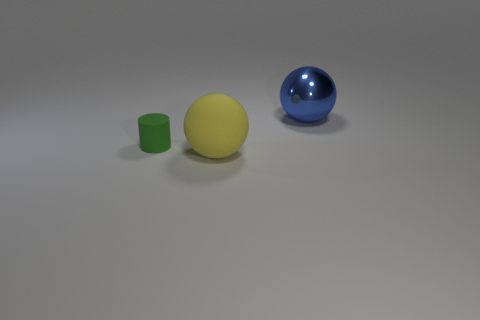Is there anything else that is the same material as the blue thing?
Keep it short and to the point. No. Is there any other thing that has the same size as the green rubber object?
Give a very brief answer. No. There is a object that is right of the small object and behind the yellow matte sphere; what is its shape?
Provide a succinct answer. Sphere. Are there the same number of yellow matte spheres that are to the right of the large yellow matte thing and large blue shiny balls to the left of the green rubber cylinder?
Keep it short and to the point. Yes. Are there any large red balls made of the same material as the cylinder?
Offer a terse response. No. Does the big sphere that is in front of the small rubber thing have the same material as the blue sphere?
Your response must be concise. No. What is the size of the thing that is on the left side of the metallic sphere and right of the matte cylinder?
Your answer should be very brief. Large. The large matte ball has what color?
Ensure brevity in your answer.  Yellow. What number of cyan rubber cylinders are there?
Your response must be concise. 0. How many other spheres are the same color as the big shiny sphere?
Your response must be concise. 0. 